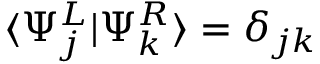<formula> <loc_0><loc_0><loc_500><loc_500>\langle \Psi _ { j } ^ { L } | \Psi _ { k } ^ { R } \rangle = \delta _ { j k }</formula> 